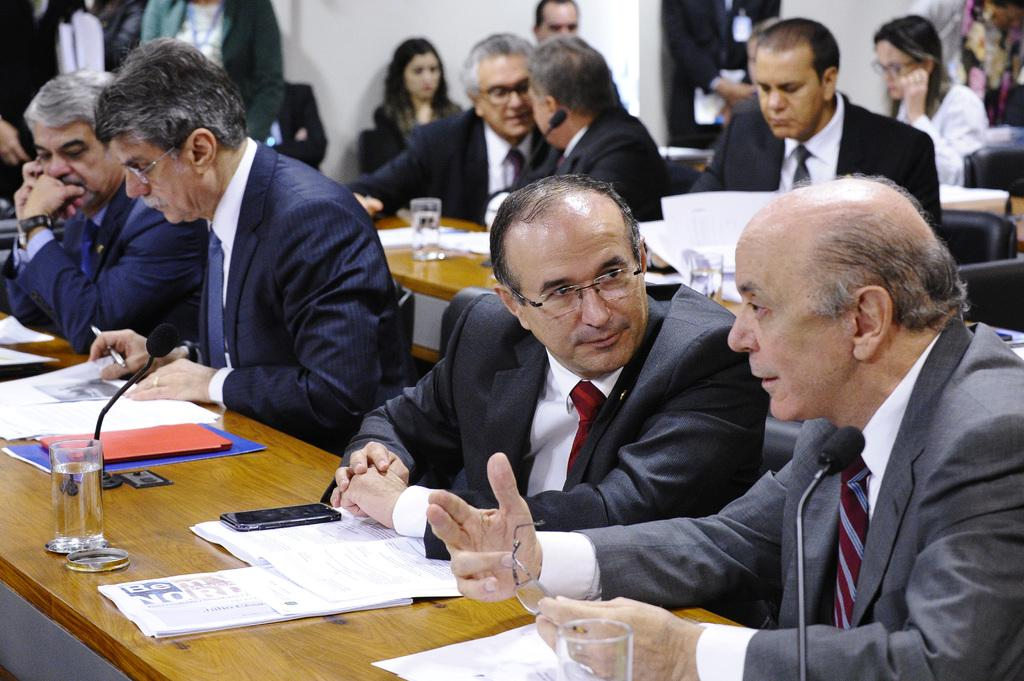What are the men in the image doing? The men in the image are sitting on chairs and talking to each other. What type of clothing are the men wearing? The men are wearing coats, ties, and shirts. What can be seen on the table in the image? There are water glasses on the table. What type of comb is being used by the men in the image? There is no comb visible in the image; the men are wearing ties and shirts, but no combs are mentioned or shown. 